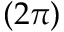Convert formula to latex. <formula><loc_0><loc_0><loc_500><loc_500>( 2 \pi )</formula> 